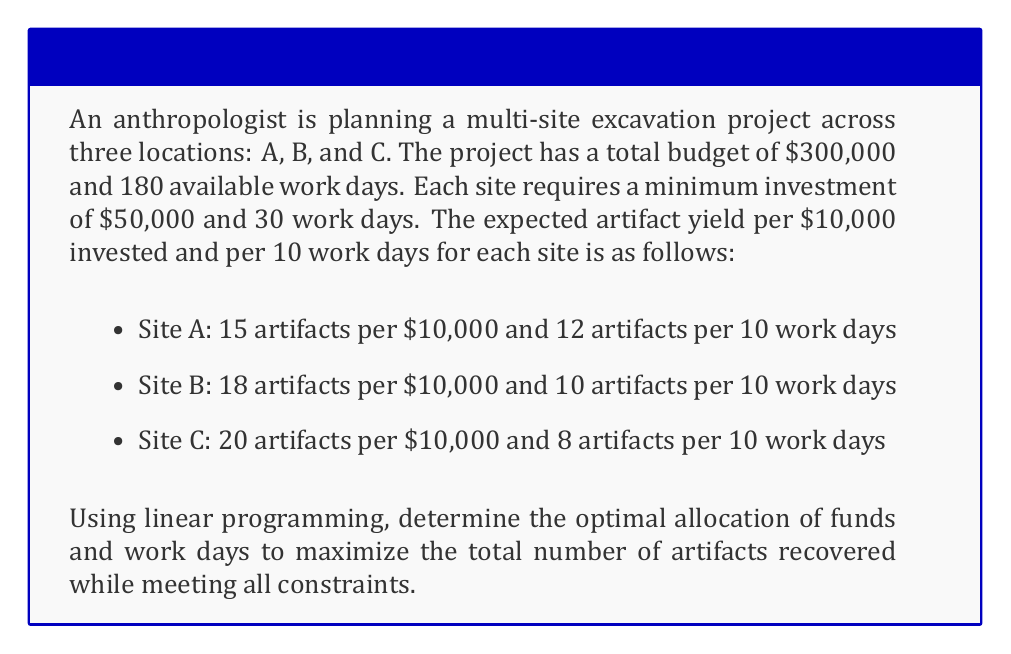Solve this math problem. To solve this problem using linear programming, we need to follow these steps:

1. Define the decision variables:
   Let $x_A$, $x_B$, and $x_C$ be the amount of money (in $10,000 units) allocated to sites A, B, and C respectively.
   Let $y_A$, $y_B$, and $y_C$ be the number of work days (in 10-day units) allocated to sites A, B, and C respectively.

2. Set up the objective function:
   Maximize $Z = 15x_A + 12y_A + 18x_B + 10y_B + 20x_C + 8y_C$

3. Define the constraints:
   a) Budget constraint: $10x_A + 10x_B + 10x_C \leq 30$ (in $10,000 units)
   b) Time constraint: $y_A + y_B + y_C \leq 18$ (in 10-day units)
   c) Minimum investment constraints:
      $10x_A \geq 5$, $10x_B \geq 5$, $10x_C \geq 5$ (in $10,000 units)
      $y_A \geq 3$, $y_B \geq 3$, $y_C \geq 3$ (in 10-day units)
   d) Non-negativity constraints:
      $x_A, x_B, x_C, y_A, y_B, y_C \geq 0$

4. Solve the linear programming problem:
   Using a linear programming solver (e.g., simplex method), we obtain the following optimal solution:

   $x_A = 5$, $x_B = 5$, $x_C = 20$
   $y_A = 3$, $y_B = 3$, $y_C = 12$

5. Interpret the results:
   Site A: $50,000 and 30 work days
   Site B: $50,000 and 30 work days
   Site C: $200,000 and 120 work days

   The maximum number of artifacts recovered:
   $Z = 15(5) + 12(3) + 18(5) + 10(3) + 20(20) + 8(12) = 571$

This allocation satisfies all constraints and maximizes the total number of artifacts recovered.
Answer: The optimal allocation is:
Site A: $50,000 and 30 work days
Site B: $50,000 and 30 work days
Site C: $200,000 and 120 work days

Maximum number of artifacts recovered: 571 